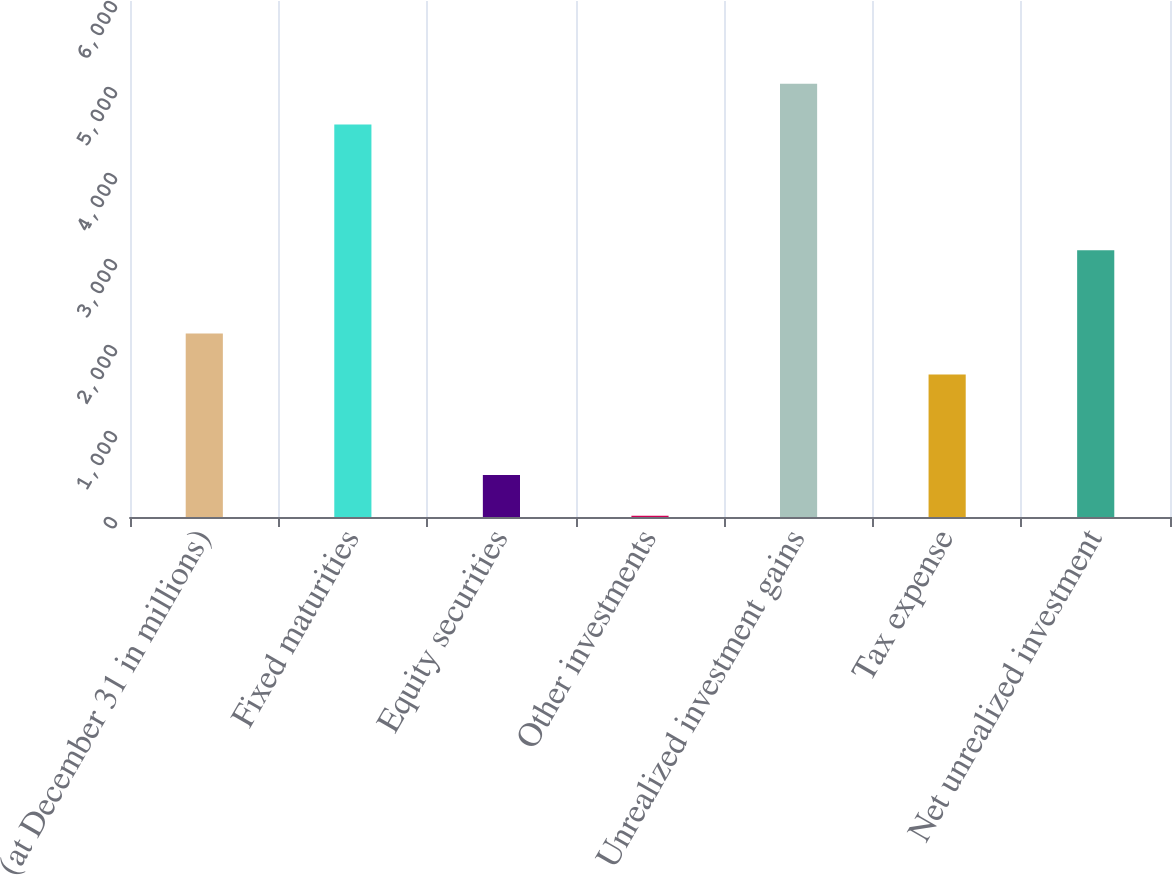Convert chart. <chart><loc_0><loc_0><loc_500><loc_500><bar_chart><fcel>(at December 31 in millions)<fcel>Fixed maturities<fcel>Equity securities<fcel>Other investments<fcel>Unrealized investment gains<fcel>Tax expense<fcel>Net unrealized investment<nl><fcel>2132.7<fcel>4564<fcel>488.7<fcel>14<fcel>5038.7<fcel>1658<fcel>3103<nl></chart> 